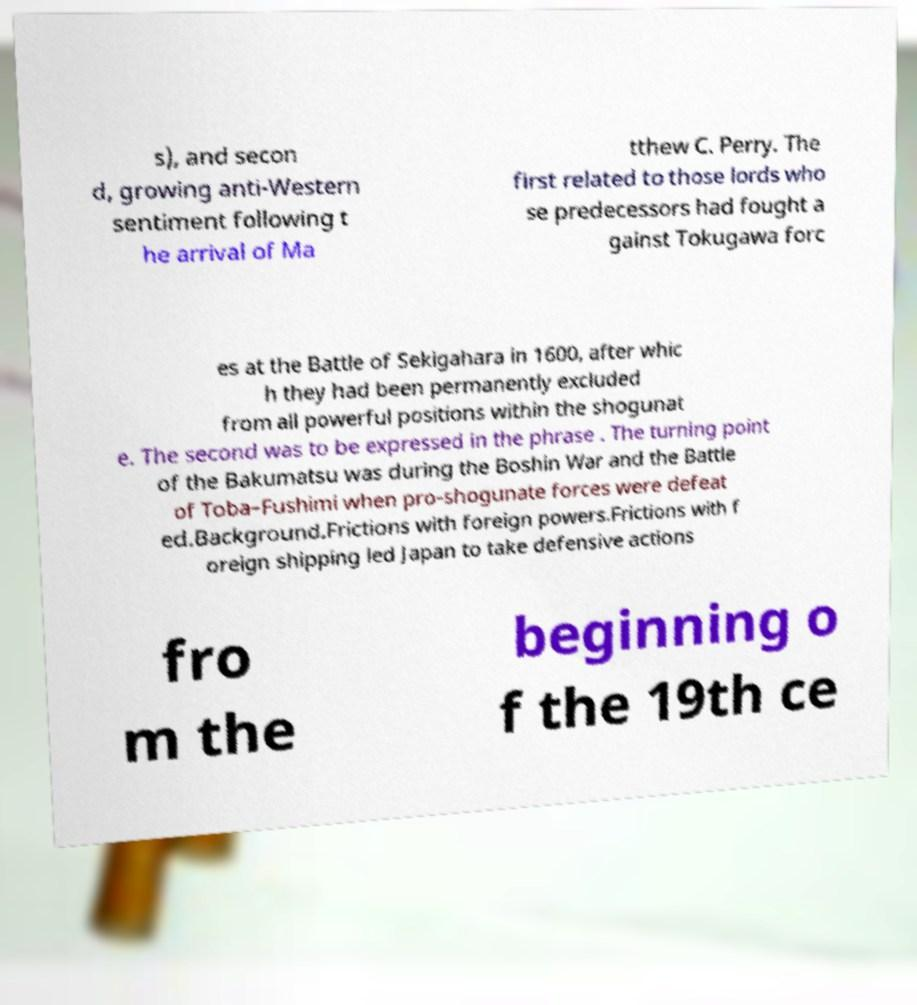Please read and relay the text visible in this image. What does it say? s), and secon d, growing anti-Western sentiment following t he arrival of Ma tthew C. Perry. The first related to those lords who se predecessors had fought a gainst Tokugawa forc es at the Battle of Sekigahara in 1600, after whic h they had been permanently excluded from all powerful positions within the shogunat e. The second was to be expressed in the phrase . The turning point of the Bakumatsu was during the Boshin War and the Battle of Toba–Fushimi when pro-shogunate forces were defeat ed.Background.Frictions with foreign powers.Frictions with f oreign shipping led Japan to take defensive actions fro m the beginning o f the 19th ce 